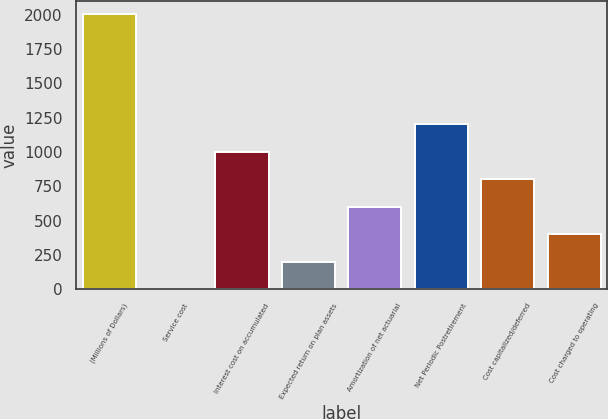Convert chart to OTSL. <chart><loc_0><loc_0><loc_500><loc_500><bar_chart><fcel>(Millions of Dollars)<fcel>Service cost<fcel>Interest cost on accumulated<fcel>Expected return on plan assets<fcel>Amortization of net actuarial<fcel>Net Periodic Postretirement<fcel>Cost capitalized/deferred<fcel>Cost charged to operating<nl><fcel>2003<fcel>2<fcel>1002.5<fcel>202.1<fcel>602.3<fcel>1202.6<fcel>802.4<fcel>402.2<nl></chart> 